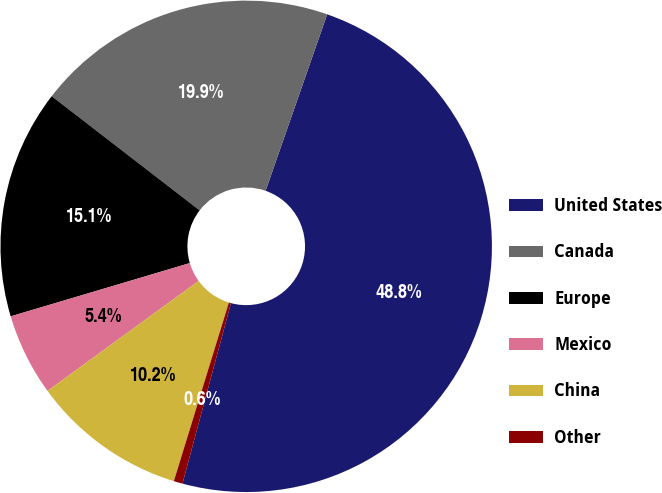Convert chart to OTSL. <chart><loc_0><loc_0><loc_500><loc_500><pie_chart><fcel>United States<fcel>Canada<fcel>Europe<fcel>Mexico<fcel>China<fcel>Other<nl><fcel>48.83%<fcel>19.88%<fcel>15.06%<fcel>5.41%<fcel>10.23%<fcel>0.58%<nl></chart> 